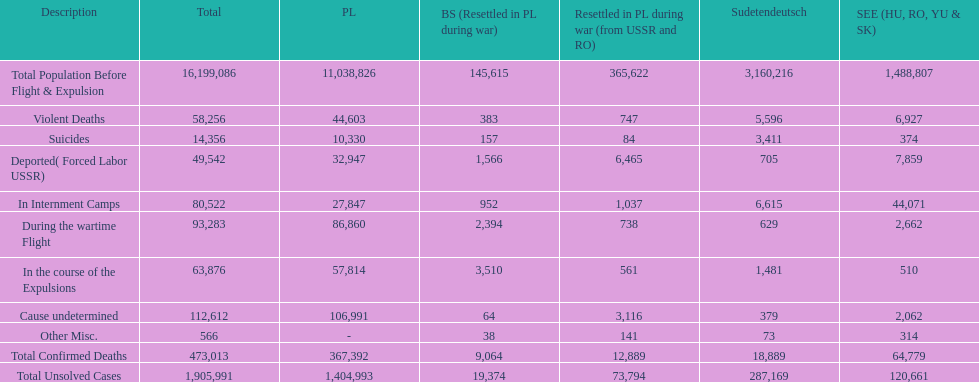What is the difference between suicides in poland and sudetendeutsch? 6919. Can you parse all the data within this table? {'header': ['Description', 'Total', 'PL', 'BS (Resettled in PL during war)', 'Resettled in PL during war (from USSR and RO)', 'Sudetendeutsch', 'SEE (HU, RO, YU & SK)'], 'rows': [['Total Population Before Flight & Expulsion', '16,199,086', '11,038,826', '145,615', '365,622', '3,160,216', '1,488,807'], ['Violent Deaths', '58,256', '44,603', '383', '747', '5,596', '6,927'], ['Suicides', '14,356', '10,330', '157', '84', '3,411', '374'], ['Deported( Forced Labor USSR)', '49,542', '32,947', '1,566', '6,465', '705', '7,859'], ['In Internment Camps', '80,522', '27,847', '952', '1,037', '6,615', '44,071'], ['During the wartime Flight', '93,283', '86,860', '2,394', '738', '629', '2,662'], ['In the course of the Expulsions', '63,876', '57,814', '3,510', '561', '1,481', '510'], ['Cause undetermined', '112,612', '106,991', '64', '3,116', '379', '2,062'], ['Other Misc.', '566', '-', '38', '141', '73', '314'], ['Total Confirmed Deaths', '473,013', '367,392', '9,064', '12,889', '18,889', '64,779'], ['Total Unsolved Cases', '1,905,991', '1,404,993', '19,374', '73,794', '287,169', '120,661']]} 